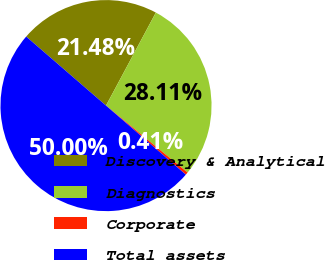Convert chart. <chart><loc_0><loc_0><loc_500><loc_500><pie_chart><fcel>Discovery & Analytical<fcel>Diagnostics<fcel>Corporate<fcel>Total assets<nl><fcel>21.48%<fcel>28.11%<fcel>0.41%<fcel>50.0%<nl></chart> 